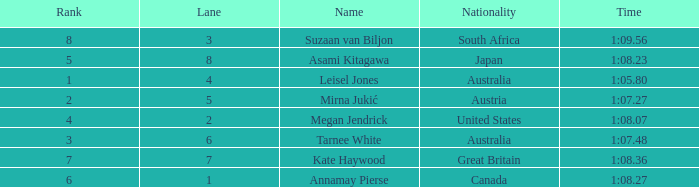What is the Nationality of the Swimmer in Lane 4 or larger with a Rank of 5 or more? Great Britain. 